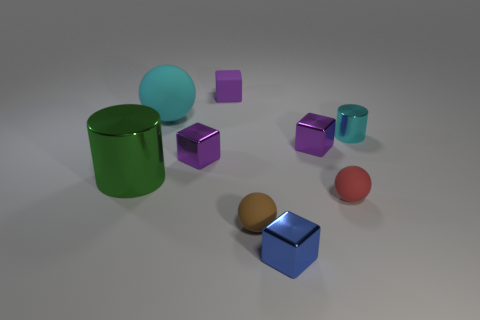How many purple blocks must be subtracted to get 1 purple blocks? 2 Subtract all tiny spheres. How many spheres are left? 1 Subtract all cyan cylinders. How many cylinders are left? 1 Subtract all cylinders. How many objects are left? 7 Subtract 2 spheres. How many spheres are left? 1 Subtract all cyan cylinders. How many brown spheres are left? 1 Subtract all blue things. Subtract all tiny gray cylinders. How many objects are left? 8 Add 2 small cyan metallic cylinders. How many small cyan metallic cylinders are left? 3 Add 6 blue matte balls. How many blue matte balls exist? 6 Subtract 0 green blocks. How many objects are left? 9 